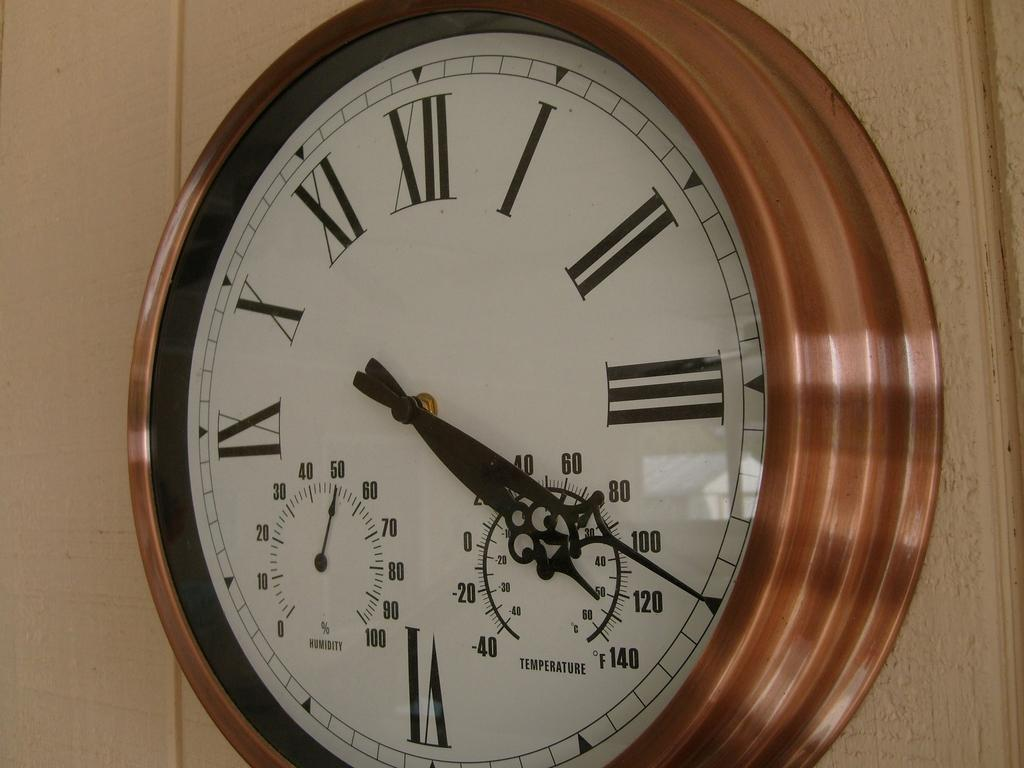<image>
Provide a brief description of the given image. The clock on the wall also shows the Temperature and the Humidity. 